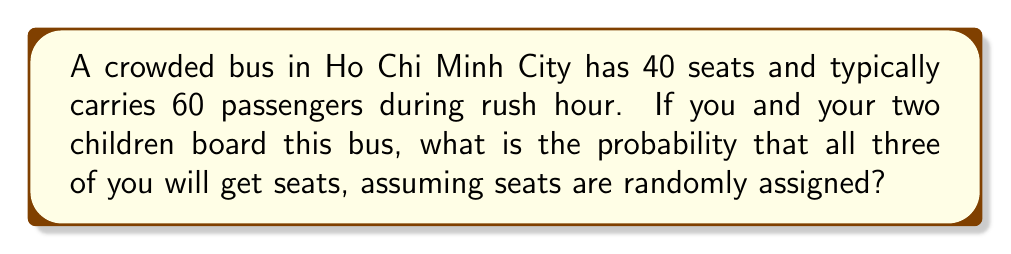What is the answer to this math problem? Let's approach this step-by-step:

1) First, we need to calculate the total number of ways to choose seats for you and your children:
   $$\binom{40}{3} = \frac{40!}{3!(40-3)!} = \frac{40 \cdot 39 \cdot 38}{3 \cdot 2 \cdot 1} = 9880$$

2) Now, we need to calculate the total number of ways to choose 3 people from the 60 passengers:
   $$\binom{60}{3} = \frac{60!}{3!(60-3)!} = \frac{60 \cdot 59 \cdot 58}{3 \cdot 2 \cdot 1} = 34220$$

3) The probability is the number of favorable outcomes divided by the total number of possible outcomes:

   $$P(\text{all three get seats}) = \frac{\binom{40}{3}}{\binom{60}{3}} = \frac{9880}{34220}$$

4) Simplifying this fraction:
   $$\frac{9880}{34220} = \frac{494}{1711} \approx 0.2887$$

5) Converting to a percentage:
   $$0.2887 \cdot 100\% \approx 28.87\%$$

Therefore, the probability that all three of you will get seats is approximately 28.87% or about 29%.
Answer: $\frac{494}{1711}$ or approximately 28.87% 